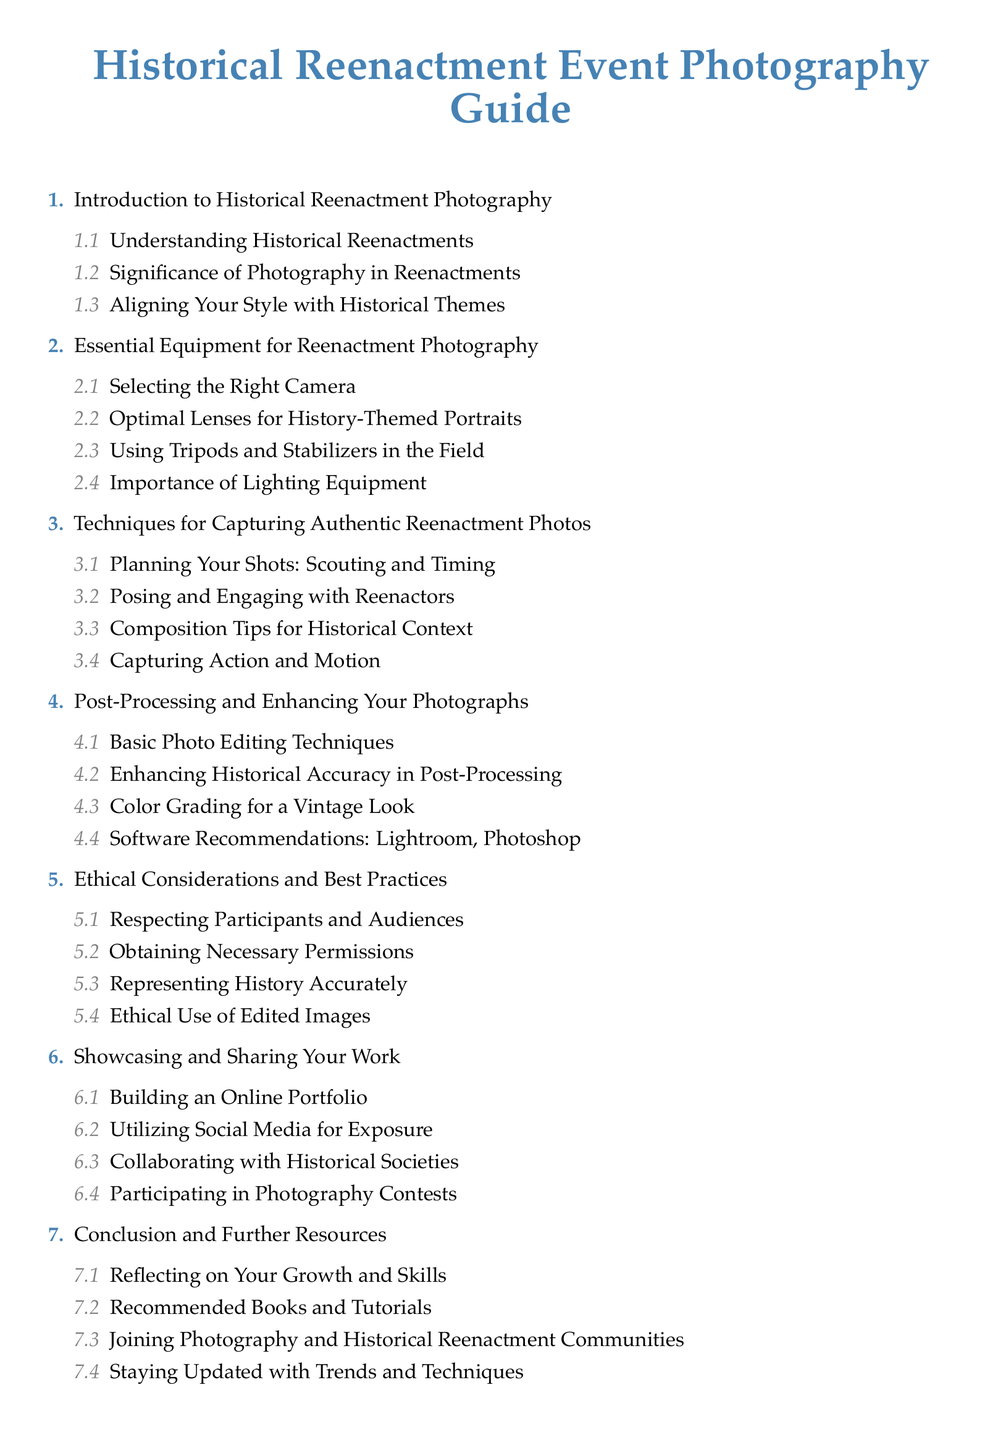What is the title of the document? The title of the document is prominently displayed at the top of the Table of Contents.
Answer: Historical Reenactment Event Photography Guide How many main sections are in the document? The number of main sections can be counted from the list shown in the Table of Contents.
Answer: 7 What is the first subtopic under 'Introduction to Historical Reenactment Photography'? The subtopics are listed under each main section, with 'Understanding Historical Reenactments' appearing first.
Answer: Understanding Historical Reenactments Which equipment is emphasized for use in the field? The equipment section lists specific gear for historical reenactment photography, highlighting tripods.
Answer: Tripods What is the focus of the section on post-processing? The post-processing section discusses techniques, focusing on enhancing images for historical accuracy.
Answer: Enhancing Historical Accuracy in Post-Processing What ethical practice is highlighted in the document? The ethical considerations section discusses maintaining respect for participants, showing its importance.
Answer: Respecting Participants and Audiences Which software is recommended for post-processing? The document mentions software options specifically for editing photos in the relevant section.
Answer: Lightroom, Photoshop 